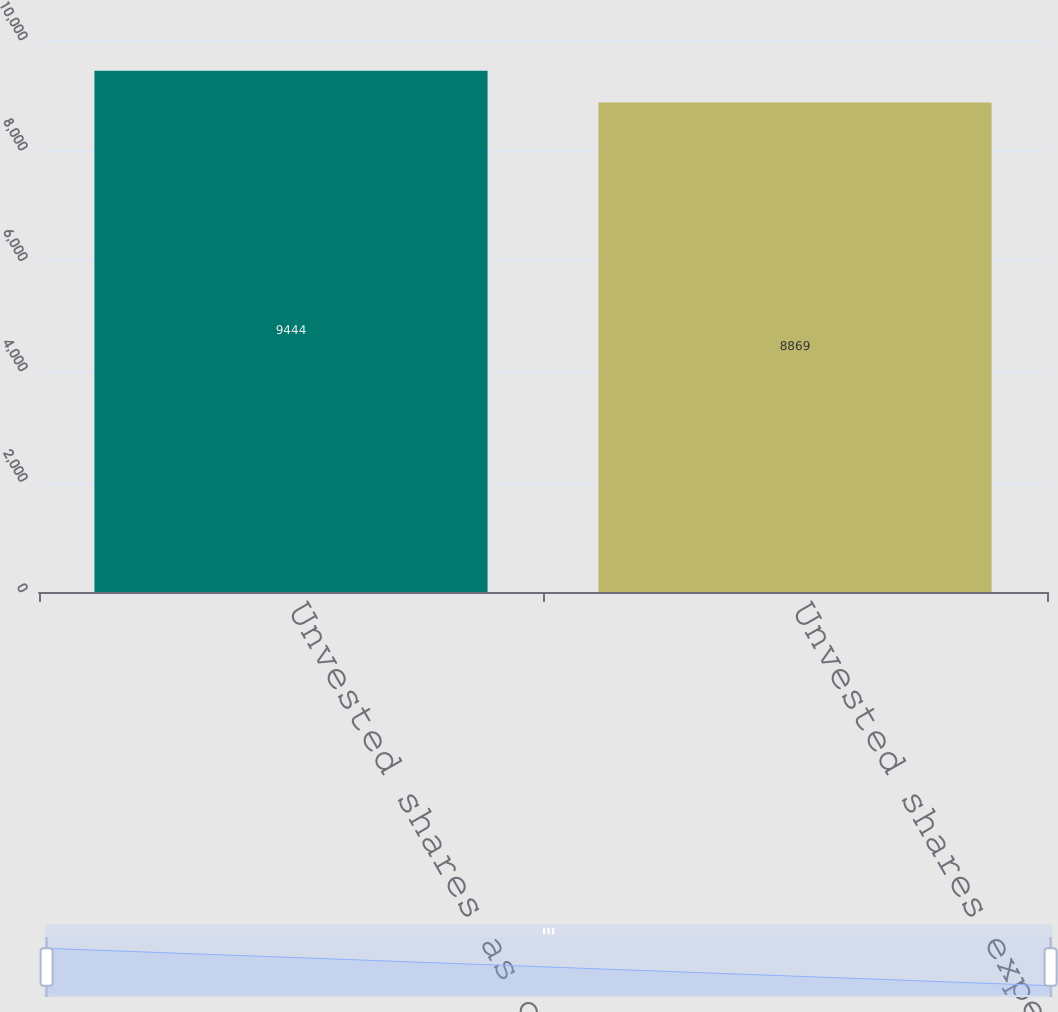Convert chart to OTSL. <chart><loc_0><loc_0><loc_500><loc_500><bar_chart><fcel>Unvested shares as of December<fcel>Unvested shares expected to<nl><fcel>9444<fcel>8869<nl></chart> 